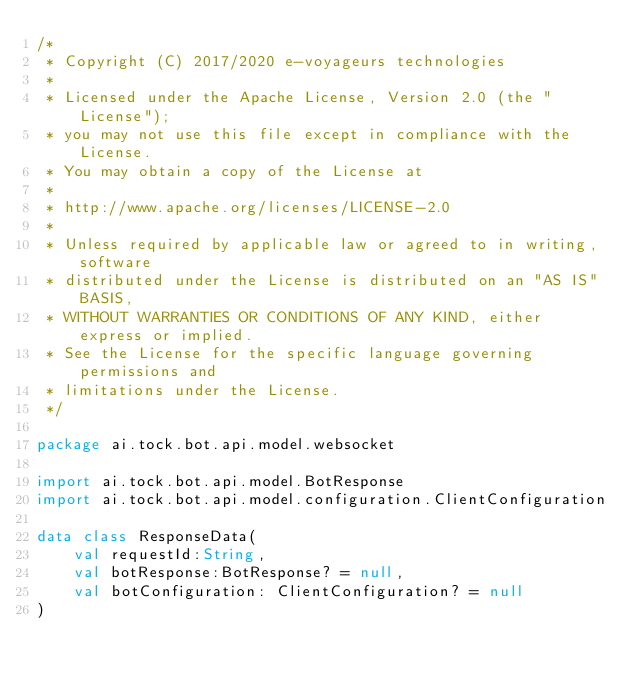Convert code to text. <code><loc_0><loc_0><loc_500><loc_500><_Kotlin_>/*
 * Copyright (C) 2017/2020 e-voyageurs technologies
 *
 * Licensed under the Apache License, Version 2.0 (the "License");
 * you may not use this file except in compliance with the License.
 * You may obtain a copy of the License at
 *
 * http://www.apache.org/licenses/LICENSE-2.0
 *
 * Unless required by applicable law or agreed to in writing, software
 * distributed under the License is distributed on an "AS IS" BASIS,
 * WITHOUT WARRANTIES OR CONDITIONS OF ANY KIND, either express or implied.
 * See the License for the specific language governing permissions and
 * limitations under the License.
 */

package ai.tock.bot.api.model.websocket

import ai.tock.bot.api.model.BotResponse
import ai.tock.bot.api.model.configuration.ClientConfiguration

data class ResponseData(
    val requestId:String,
    val botResponse:BotResponse? = null,
    val botConfiguration: ClientConfiguration? = null
)</code> 